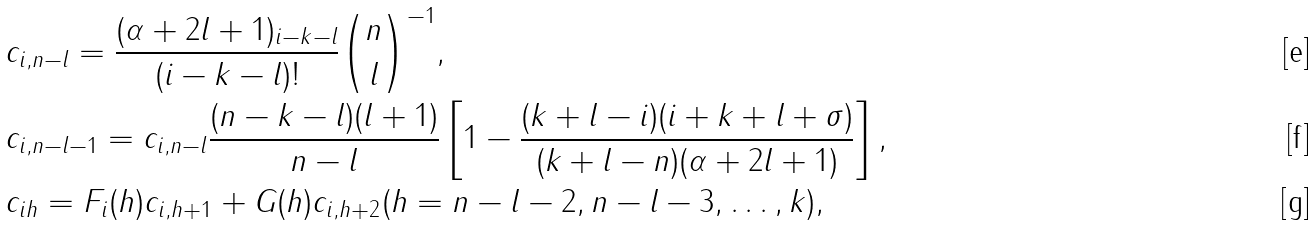<formula> <loc_0><loc_0><loc_500><loc_500>& c _ { i , n - l } = \frac { ( \alpha + 2 l + 1 ) _ { i - k - l } } { ( i - k - l ) ! } \binom { n } { l } ^ { - 1 } , \\ & c _ { i , n - l - 1 } = c _ { i , n - l } \frac { ( n - k - l ) ( l + 1 ) } { n - l } \left [ 1 - \frac { ( k + l - i ) ( i + k + l + \sigma ) } { ( k + l - n ) ( \alpha + 2 l + 1 ) } \right ] , \\ & c _ { i h } = F _ { i } ( h ) c _ { i , h + 1 } + G ( h ) c _ { i , h + 2 } ( h = n - l - 2 , n - l - 3 , \dots , k ) ,</formula> 